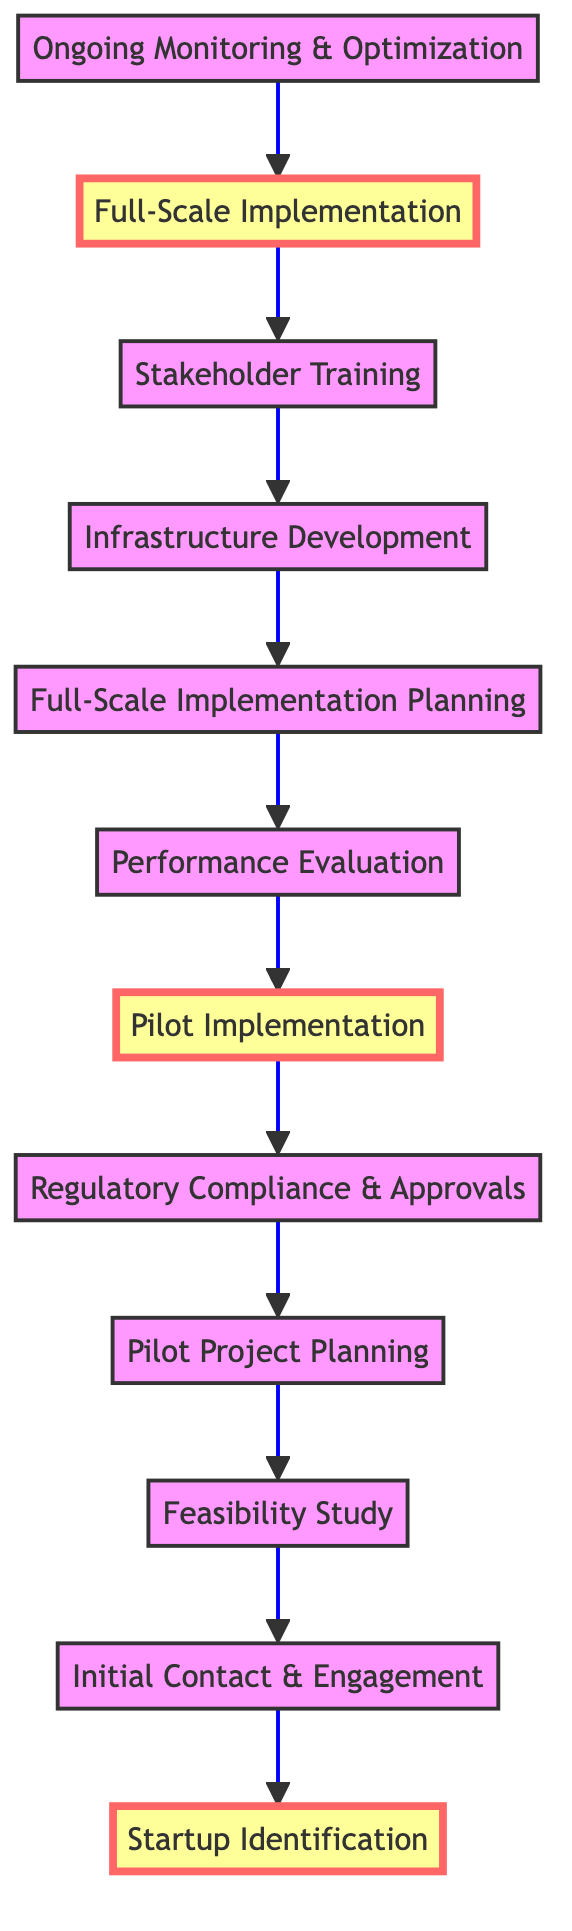What is the total number of steps in the implementation process? Counting the nodes in the flow chart demonstrates that there are twelve distinct steps that outline the entire implementation process.
Answer: twelve What is the name of the first step in the process? Looking at the bottom of the flow chart, the first step is labeled "Startup Identification."
Answer: Startup Identification Which step follows the "Pilot Implementation" step? Following the flow from bottom to top, "Pilot Implementation" is directly followed by "Performance Evaluation."
Answer: Performance Evaluation What key action is required after performance evaluation before full-scale implementation? Upon completion of "Performance Evaluation," the next required action is to plan for "Full-Scale Implementation Planning."
Answer: Full-Scale Implementation Planning How many steps are in between "Initial Contact & Engagement" and "Pilot Implementation"? Counting the steps that flow between these two nodes, we find that there are four intervening steps: "Feasibility Study," "Pilot Project Planning," "Regulatory Compliance & Approvals," and "Pilot Implementation."
Answer: four Which step is considered critical for ensuring the project aligns with legal requirements? The step designated for ensuring compliance with legal requirements is "Regulatory Compliance & Approvals."
Answer: Regulatory Compliance & Approvals What is the last step in the process? Reviewing the flow chart from bottom to top, the last step noted is "Ongoing Monitoring & Optimization."
Answer: Ongoing Monitoring & Optimization What two steps are highlighted in the diagram? The highlighted steps within the flow chart indicate "Startup Identification" and "Full-Scale Implementation."
Answer: Startup Identification, Full-Scale Implementation What is the immediate subsequent step after "Ongoing Monitoring & Optimization"? As per the directional flow, there is no step following "Ongoing Monitoring & Optimization" because it is the concluding step of the process.
Answer: none 